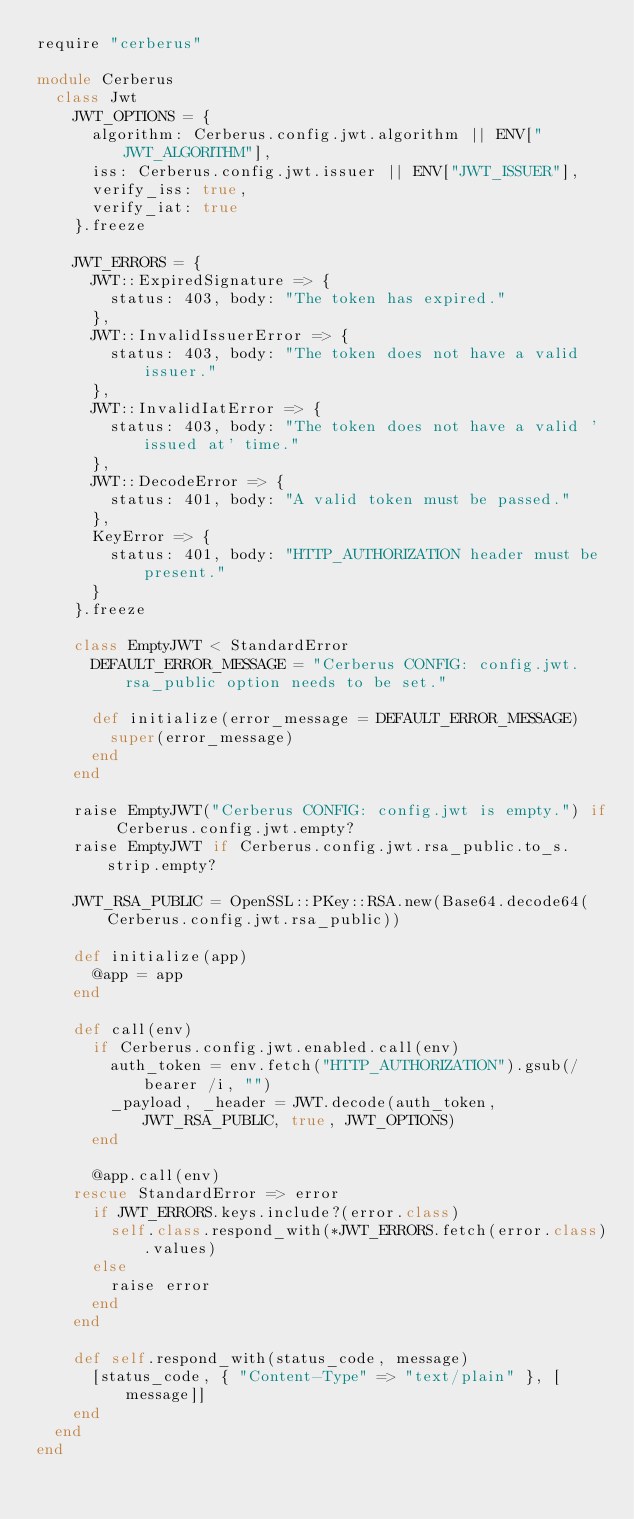Convert code to text. <code><loc_0><loc_0><loc_500><loc_500><_Ruby_>require "cerberus"

module Cerberus
  class Jwt
    JWT_OPTIONS = {
      algorithm: Cerberus.config.jwt.algorithm || ENV["JWT_ALGORITHM"],
      iss: Cerberus.config.jwt.issuer || ENV["JWT_ISSUER"],
      verify_iss: true,
      verify_iat: true
    }.freeze

    JWT_ERRORS = {
      JWT::ExpiredSignature => {
        status: 403, body: "The token has expired."
      },
      JWT::InvalidIssuerError => {
        status: 403, body: "The token does not have a valid issuer."
      },
      JWT::InvalidIatError => {
        status: 403, body: "The token does not have a valid 'issued at' time."
      },
      JWT::DecodeError => {
        status: 401, body: "A valid token must be passed."
      },
      KeyError => {
        status: 401, body: "HTTP_AUTHORIZATION header must be present."
      }
    }.freeze

    class EmptyJWT < StandardError
      DEFAULT_ERROR_MESSAGE = "Cerberus CONFIG: config.jwt.rsa_public option needs to be set."

      def initialize(error_message = DEFAULT_ERROR_MESSAGE)
        super(error_message)
      end
    end

    raise EmptyJWT("Cerberus CONFIG: config.jwt is empty.") if Cerberus.config.jwt.empty?
    raise EmptyJWT if Cerberus.config.jwt.rsa_public.to_s.strip.empty?

    JWT_RSA_PUBLIC = OpenSSL::PKey::RSA.new(Base64.decode64(Cerberus.config.jwt.rsa_public))

    def initialize(app)
      @app = app
    end

    def call(env)
      if Cerberus.config.jwt.enabled.call(env)
        auth_token = env.fetch("HTTP_AUTHORIZATION").gsub(/bearer /i, "")
        _payload, _header = JWT.decode(auth_token, JWT_RSA_PUBLIC, true, JWT_OPTIONS)
      end

      @app.call(env)
    rescue StandardError => error
      if JWT_ERRORS.keys.include?(error.class)
        self.class.respond_with(*JWT_ERRORS.fetch(error.class).values)
      else
        raise error
      end
    end

    def self.respond_with(status_code, message)
      [status_code, { "Content-Type" => "text/plain" }, [message]]
    end
  end
end
</code> 